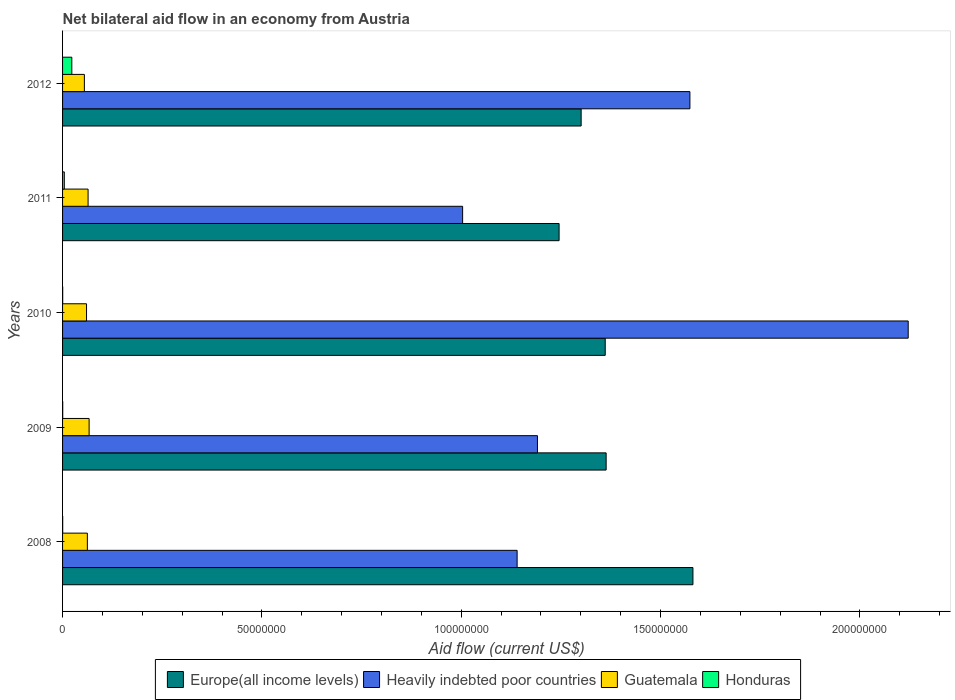Are the number of bars per tick equal to the number of legend labels?
Your answer should be compact. Yes. How many bars are there on the 5th tick from the top?
Keep it short and to the point. 4. Across all years, what is the maximum net bilateral aid flow in Guatemala?
Your answer should be very brief. 6.66e+06. Across all years, what is the minimum net bilateral aid flow in Europe(all income levels)?
Ensure brevity in your answer.  1.25e+08. What is the total net bilateral aid flow in Heavily indebted poor countries in the graph?
Ensure brevity in your answer.  7.03e+08. What is the difference between the net bilateral aid flow in Europe(all income levels) in 2010 and the net bilateral aid flow in Heavily indebted poor countries in 2009?
Offer a terse response. 1.70e+07. What is the average net bilateral aid flow in Heavily indebted poor countries per year?
Offer a terse response. 1.41e+08. In the year 2011, what is the difference between the net bilateral aid flow in Europe(all income levels) and net bilateral aid flow in Guatemala?
Give a very brief answer. 1.18e+08. In how many years, is the net bilateral aid flow in Europe(all income levels) greater than 60000000 US$?
Make the answer very short. 5. What is the ratio of the net bilateral aid flow in Heavily indebted poor countries in 2009 to that in 2011?
Offer a terse response. 1.19. Is the difference between the net bilateral aid flow in Europe(all income levels) in 2008 and 2010 greater than the difference between the net bilateral aid flow in Guatemala in 2008 and 2010?
Keep it short and to the point. Yes. What is the difference between the highest and the second highest net bilateral aid flow in Heavily indebted poor countries?
Provide a succinct answer. 5.48e+07. What is the difference between the highest and the lowest net bilateral aid flow in Honduras?
Offer a terse response. 2.29e+06. Is the sum of the net bilateral aid flow in Europe(all income levels) in 2009 and 2011 greater than the maximum net bilateral aid flow in Heavily indebted poor countries across all years?
Provide a short and direct response. Yes. What does the 2nd bar from the top in 2008 represents?
Make the answer very short. Guatemala. What does the 2nd bar from the bottom in 2011 represents?
Provide a short and direct response. Heavily indebted poor countries. How many bars are there?
Provide a succinct answer. 20. How many years are there in the graph?
Your answer should be very brief. 5. Does the graph contain any zero values?
Your response must be concise. No. Where does the legend appear in the graph?
Provide a short and direct response. Bottom center. What is the title of the graph?
Keep it short and to the point. Net bilateral aid flow in an economy from Austria. Does "Spain" appear as one of the legend labels in the graph?
Your answer should be very brief. No. What is the Aid flow (current US$) in Europe(all income levels) in 2008?
Offer a very short reply. 1.58e+08. What is the Aid flow (current US$) in Heavily indebted poor countries in 2008?
Provide a succinct answer. 1.14e+08. What is the Aid flow (current US$) in Guatemala in 2008?
Offer a very short reply. 6.22e+06. What is the Aid flow (current US$) of Honduras in 2008?
Your answer should be very brief. 3.00e+04. What is the Aid flow (current US$) in Europe(all income levels) in 2009?
Your answer should be very brief. 1.36e+08. What is the Aid flow (current US$) of Heavily indebted poor countries in 2009?
Offer a very short reply. 1.19e+08. What is the Aid flow (current US$) in Guatemala in 2009?
Your answer should be very brief. 6.66e+06. What is the Aid flow (current US$) of Europe(all income levels) in 2010?
Ensure brevity in your answer.  1.36e+08. What is the Aid flow (current US$) of Heavily indebted poor countries in 2010?
Ensure brevity in your answer.  2.12e+08. What is the Aid flow (current US$) of Guatemala in 2010?
Offer a terse response. 6.01e+06. What is the Aid flow (current US$) of Honduras in 2010?
Provide a succinct answer. 3.00e+04. What is the Aid flow (current US$) in Europe(all income levels) in 2011?
Ensure brevity in your answer.  1.25e+08. What is the Aid flow (current US$) in Heavily indebted poor countries in 2011?
Provide a succinct answer. 1.00e+08. What is the Aid flow (current US$) in Guatemala in 2011?
Give a very brief answer. 6.40e+06. What is the Aid flow (current US$) of Europe(all income levels) in 2012?
Ensure brevity in your answer.  1.30e+08. What is the Aid flow (current US$) in Heavily indebted poor countries in 2012?
Make the answer very short. 1.57e+08. What is the Aid flow (current US$) of Guatemala in 2012?
Offer a terse response. 5.47e+06. What is the Aid flow (current US$) of Honduras in 2012?
Ensure brevity in your answer.  2.32e+06. Across all years, what is the maximum Aid flow (current US$) in Europe(all income levels)?
Ensure brevity in your answer.  1.58e+08. Across all years, what is the maximum Aid flow (current US$) in Heavily indebted poor countries?
Ensure brevity in your answer.  2.12e+08. Across all years, what is the maximum Aid flow (current US$) of Guatemala?
Your answer should be compact. 6.66e+06. Across all years, what is the maximum Aid flow (current US$) of Honduras?
Ensure brevity in your answer.  2.32e+06. Across all years, what is the minimum Aid flow (current US$) in Europe(all income levels)?
Your answer should be compact. 1.25e+08. Across all years, what is the minimum Aid flow (current US$) of Heavily indebted poor countries?
Provide a short and direct response. 1.00e+08. Across all years, what is the minimum Aid flow (current US$) of Guatemala?
Give a very brief answer. 5.47e+06. What is the total Aid flow (current US$) of Europe(all income levels) in the graph?
Offer a terse response. 6.85e+08. What is the total Aid flow (current US$) in Heavily indebted poor countries in the graph?
Offer a very short reply. 7.03e+08. What is the total Aid flow (current US$) of Guatemala in the graph?
Give a very brief answer. 3.08e+07. What is the total Aid flow (current US$) in Honduras in the graph?
Your answer should be compact. 2.86e+06. What is the difference between the Aid flow (current US$) of Europe(all income levels) in 2008 and that in 2009?
Offer a very short reply. 2.18e+07. What is the difference between the Aid flow (current US$) of Heavily indebted poor countries in 2008 and that in 2009?
Keep it short and to the point. -5.10e+06. What is the difference between the Aid flow (current US$) in Guatemala in 2008 and that in 2009?
Offer a very short reply. -4.40e+05. What is the difference between the Aid flow (current US$) of Honduras in 2008 and that in 2009?
Provide a short and direct response. -10000. What is the difference between the Aid flow (current US$) in Europe(all income levels) in 2008 and that in 2010?
Ensure brevity in your answer.  2.20e+07. What is the difference between the Aid flow (current US$) of Heavily indebted poor countries in 2008 and that in 2010?
Your answer should be very brief. -9.81e+07. What is the difference between the Aid flow (current US$) in Honduras in 2008 and that in 2010?
Ensure brevity in your answer.  0. What is the difference between the Aid flow (current US$) of Europe(all income levels) in 2008 and that in 2011?
Offer a terse response. 3.36e+07. What is the difference between the Aid flow (current US$) in Heavily indebted poor countries in 2008 and that in 2011?
Your answer should be very brief. 1.37e+07. What is the difference between the Aid flow (current US$) in Guatemala in 2008 and that in 2011?
Your answer should be very brief. -1.80e+05. What is the difference between the Aid flow (current US$) of Honduras in 2008 and that in 2011?
Offer a terse response. -4.10e+05. What is the difference between the Aid flow (current US$) of Europe(all income levels) in 2008 and that in 2012?
Your answer should be very brief. 2.80e+07. What is the difference between the Aid flow (current US$) of Heavily indebted poor countries in 2008 and that in 2012?
Your answer should be compact. -4.33e+07. What is the difference between the Aid flow (current US$) of Guatemala in 2008 and that in 2012?
Your response must be concise. 7.50e+05. What is the difference between the Aid flow (current US$) of Honduras in 2008 and that in 2012?
Ensure brevity in your answer.  -2.29e+06. What is the difference between the Aid flow (current US$) in Heavily indebted poor countries in 2009 and that in 2010?
Offer a very short reply. -9.30e+07. What is the difference between the Aid flow (current US$) in Guatemala in 2009 and that in 2010?
Your answer should be compact. 6.50e+05. What is the difference between the Aid flow (current US$) of Europe(all income levels) in 2009 and that in 2011?
Your answer should be very brief. 1.18e+07. What is the difference between the Aid flow (current US$) of Heavily indebted poor countries in 2009 and that in 2011?
Provide a short and direct response. 1.88e+07. What is the difference between the Aid flow (current US$) in Honduras in 2009 and that in 2011?
Offer a very short reply. -4.00e+05. What is the difference between the Aid flow (current US$) in Europe(all income levels) in 2009 and that in 2012?
Make the answer very short. 6.27e+06. What is the difference between the Aid flow (current US$) in Heavily indebted poor countries in 2009 and that in 2012?
Make the answer very short. -3.82e+07. What is the difference between the Aid flow (current US$) of Guatemala in 2009 and that in 2012?
Offer a terse response. 1.19e+06. What is the difference between the Aid flow (current US$) in Honduras in 2009 and that in 2012?
Ensure brevity in your answer.  -2.28e+06. What is the difference between the Aid flow (current US$) in Europe(all income levels) in 2010 and that in 2011?
Your response must be concise. 1.16e+07. What is the difference between the Aid flow (current US$) of Heavily indebted poor countries in 2010 and that in 2011?
Keep it short and to the point. 1.12e+08. What is the difference between the Aid flow (current US$) of Guatemala in 2010 and that in 2011?
Your answer should be compact. -3.90e+05. What is the difference between the Aid flow (current US$) in Honduras in 2010 and that in 2011?
Make the answer very short. -4.10e+05. What is the difference between the Aid flow (current US$) of Europe(all income levels) in 2010 and that in 2012?
Keep it short and to the point. 6.04e+06. What is the difference between the Aid flow (current US$) of Heavily indebted poor countries in 2010 and that in 2012?
Provide a short and direct response. 5.48e+07. What is the difference between the Aid flow (current US$) in Guatemala in 2010 and that in 2012?
Provide a short and direct response. 5.40e+05. What is the difference between the Aid flow (current US$) in Honduras in 2010 and that in 2012?
Keep it short and to the point. -2.29e+06. What is the difference between the Aid flow (current US$) in Europe(all income levels) in 2011 and that in 2012?
Ensure brevity in your answer.  -5.53e+06. What is the difference between the Aid flow (current US$) in Heavily indebted poor countries in 2011 and that in 2012?
Your answer should be very brief. -5.70e+07. What is the difference between the Aid flow (current US$) in Guatemala in 2011 and that in 2012?
Make the answer very short. 9.30e+05. What is the difference between the Aid flow (current US$) of Honduras in 2011 and that in 2012?
Your response must be concise. -1.88e+06. What is the difference between the Aid flow (current US$) of Europe(all income levels) in 2008 and the Aid flow (current US$) of Heavily indebted poor countries in 2009?
Your answer should be compact. 3.90e+07. What is the difference between the Aid flow (current US$) in Europe(all income levels) in 2008 and the Aid flow (current US$) in Guatemala in 2009?
Your answer should be compact. 1.51e+08. What is the difference between the Aid flow (current US$) in Europe(all income levels) in 2008 and the Aid flow (current US$) in Honduras in 2009?
Offer a very short reply. 1.58e+08. What is the difference between the Aid flow (current US$) in Heavily indebted poor countries in 2008 and the Aid flow (current US$) in Guatemala in 2009?
Your response must be concise. 1.07e+08. What is the difference between the Aid flow (current US$) in Heavily indebted poor countries in 2008 and the Aid flow (current US$) in Honduras in 2009?
Provide a succinct answer. 1.14e+08. What is the difference between the Aid flow (current US$) in Guatemala in 2008 and the Aid flow (current US$) in Honduras in 2009?
Your response must be concise. 6.18e+06. What is the difference between the Aid flow (current US$) in Europe(all income levels) in 2008 and the Aid flow (current US$) in Heavily indebted poor countries in 2010?
Give a very brief answer. -5.40e+07. What is the difference between the Aid flow (current US$) of Europe(all income levels) in 2008 and the Aid flow (current US$) of Guatemala in 2010?
Make the answer very short. 1.52e+08. What is the difference between the Aid flow (current US$) of Europe(all income levels) in 2008 and the Aid flow (current US$) of Honduras in 2010?
Offer a very short reply. 1.58e+08. What is the difference between the Aid flow (current US$) of Heavily indebted poor countries in 2008 and the Aid flow (current US$) of Guatemala in 2010?
Your answer should be compact. 1.08e+08. What is the difference between the Aid flow (current US$) in Heavily indebted poor countries in 2008 and the Aid flow (current US$) in Honduras in 2010?
Give a very brief answer. 1.14e+08. What is the difference between the Aid flow (current US$) of Guatemala in 2008 and the Aid flow (current US$) of Honduras in 2010?
Your answer should be compact. 6.19e+06. What is the difference between the Aid flow (current US$) in Europe(all income levels) in 2008 and the Aid flow (current US$) in Heavily indebted poor countries in 2011?
Offer a very short reply. 5.78e+07. What is the difference between the Aid flow (current US$) of Europe(all income levels) in 2008 and the Aid flow (current US$) of Guatemala in 2011?
Offer a terse response. 1.52e+08. What is the difference between the Aid flow (current US$) in Europe(all income levels) in 2008 and the Aid flow (current US$) in Honduras in 2011?
Your answer should be compact. 1.58e+08. What is the difference between the Aid flow (current US$) in Heavily indebted poor countries in 2008 and the Aid flow (current US$) in Guatemala in 2011?
Offer a terse response. 1.08e+08. What is the difference between the Aid flow (current US$) in Heavily indebted poor countries in 2008 and the Aid flow (current US$) in Honduras in 2011?
Give a very brief answer. 1.14e+08. What is the difference between the Aid flow (current US$) in Guatemala in 2008 and the Aid flow (current US$) in Honduras in 2011?
Keep it short and to the point. 5.78e+06. What is the difference between the Aid flow (current US$) of Europe(all income levels) in 2008 and the Aid flow (current US$) of Heavily indebted poor countries in 2012?
Offer a very short reply. 7.60e+05. What is the difference between the Aid flow (current US$) of Europe(all income levels) in 2008 and the Aid flow (current US$) of Guatemala in 2012?
Your answer should be very brief. 1.53e+08. What is the difference between the Aid flow (current US$) in Europe(all income levels) in 2008 and the Aid flow (current US$) in Honduras in 2012?
Offer a very short reply. 1.56e+08. What is the difference between the Aid flow (current US$) in Heavily indebted poor countries in 2008 and the Aid flow (current US$) in Guatemala in 2012?
Make the answer very short. 1.09e+08. What is the difference between the Aid flow (current US$) of Heavily indebted poor countries in 2008 and the Aid flow (current US$) of Honduras in 2012?
Provide a succinct answer. 1.12e+08. What is the difference between the Aid flow (current US$) in Guatemala in 2008 and the Aid flow (current US$) in Honduras in 2012?
Give a very brief answer. 3.90e+06. What is the difference between the Aid flow (current US$) in Europe(all income levels) in 2009 and the Aid flow (current US$) in Heavily indebted poor countries in 2010?
Provide a short and direct response. -7.58e+07. What is the difference between the Aid flow (current US$) of Europe(all income levels) in 2009 and the Aid flow (current US$) of Guatemala in 2010?
Keep it short and to the point. 1.30e+08. What is the difference between the Aid flow (current US$) of Europe(all income levels) in 2009 and the Aid flow (current US$) of Honduras in 2010?
Your answer should be compact. 1.36e+08. What is the difference between the Aid flow (current US$) in Heavily indebted poor countries in 2009 and the Aid flow (current US$) in Guatemala in 2010?
Provide a succinct answer. 1.13e+08. What is the difference between the Aid flow (current US$) in Heavily indebted poor countries in 2009 and the Aid flow (current US$) in Honduras in 2010?
Provide a short and direct response. 1.19e+08. What is the difference between the Aid flow (current US$) in Guatemala in 2009 and the Aid flow (current US$) in Honduras in 2010?
Your answer should be very brief. 6.63e+06. What is the difference between the Aid flow (current US$) of Europe(all income levels) in 2009 and the Aid flow (current US$) of Heavily indebted poor countries in 2011?
Keep it short and to the point. 3.60e+07. What is the difference between the Aid flow (current US$) of Europe(all income levels) in 2009 and the Aid flow (current US$) of Guatemala in 2011?
Give a very brief answer. 1.30e+08. What is the difference between the Aid flow (current US$) in Europe(all income levels) in 2009 and the Aid flow (current US$) in Honduras in 2011?
Your response must be concise. 1.36e+08. What is the difference between the Aid flow (current US$) in Heavily indebted poor countries in 2009 and the Aid flow (current US$) in Guatemala in 2011?
Provide a succinct answer. 1.13e+08. What is the difference between the Aid flow (current US$) in Heavily indebted poor countries in 2009 and the Aid flow (current US$) in Honduras in 2011?
Make the answer very short. 1.19e+08. What is the difference between the Aid flow (current US$) of Guatemala in 2009 and the Aid flow (current US$) of Honduras in 2011?
Provide a succinct answer. 6.22e+06. What is the difference between the Aid flow (current US$) of Europe(all income levels) in 2009 and the Aid flow (current US$) of Heavily indebted poor countries in 2012?
Keep it short and to the point. -2.10e+07. What is the difference between the Aid flow (current US$) of Europe(all income levels) in 2009 and the Aid flow (current US$) of Guatemala in 2012?
Keep it short and to the point. 1.31e+08. What is the difference between the Aid flow (current US$) of Europe(all income levels) in 2009 and the Aid flow (current US$) of Honduras in 2012?
Your answer should be very brief. 1.34e+08. What is the difference between the Aid flow (current US$) of Heavily indebted poor countries in 2009 and the Aid flow (current US$) of Guatemala in 2012?
Give a very brief answer. 1.14e+08. What is the difference between the Aid flow (current US$) of Heavily indebted poor countries in 2009 and the Aid flow (current US$) of Honduras in 2012?
Offer a very short reply. 1.17e+08. What is the difference between the Aid flow (current US$) in Guatemala in 2009 and the Aid flow (current US$) in Honduras in 2012?
Your answer should be very brief. 4.34e+06. What is the difference between the Aid flow (current US$) of Europe(all income levels) in 2010 and the Aid flow (current US$) of Heavily indebted poor countries in 2011?
Keep it short and to the point. 3.58e+07. What is the difference between the Aid flow (current US$) of Europe(all income levels) in 2010 and the Aid flow (current US$) of Guatemala in 2011?
Give a very brief answer. 1.30e+08. What is the difference between the Aid flow (current US$) of Europe(all income levels) in 2010 and the Aid flow (current US$) of Honduras in 2011?
Your answer should be very brief. 1.36e+08. What is the difference between the Aid flow (current US$) of Heavily indebted poor countries in 2010 and the Aid flow (current US$) of Guatemala in 2011?
Offer a very short reply. 2.06e+08. What is the difference between the Aid flow (current US$) in Heavily indebted poor countries in 2010 and the Aid flow (current US$) in Honduras in 2011?
Ensure brevity in your answer.  2.12e+08. What is the difference between the Aid flow (current US$) of Guatemala in 2010 and the Aid flow (current US$) of Honduras in 2011?
Ensure brevity in your answer.  5.57e+06. What is the difference between the Aid flow (current US$) of Europe(all income levels) in 2010 and the Aid flow (current US$) of Heavily indebted poor countries in 2012?
Provide a succinct answer. -2.12e+07. What is the difference between the Aid flow (current US$) in Europe(all income levels) in 2010 and the Aid flow (current US$) in Guatemala in 2012?
Make the answer very short. 1.31e+08. What is the difference between the Aid flow (current US$) of Europe(all income levels) in 2010 and the Aid flow (current US$) of Honduras in 2012?
Ensure brevity in your answer.  1.34e+08. What is the difference between the Aid flow (current US$) of Heavily indebted poor countries in 2010 and the Aid flow (current US$) of Guatemala in 2012?
Make the answer very short. 2.07e+08. What is the difference between the Aid flow (current US$) of Heavily indebted poor countries in 2010 and the Aid flow (current US$) of Honduras in 2012?
Offer a terse response. 2.10e+08. What is the difference between the Aid flow (current US$) in Guatemala in 2010 and the Aid flow (current US$) in Honduras in 2012?
Offer a terse response. 3.69e+06. What is the difference between the Aid flow (current US$) in Europe(all income levels) in 2011 and the Aid flow (current US$) in Heavily indebted poor countries in 2012?
Provide a short and direct response. -3.28e+07. What is the difference between the Aid flow (current US$) of Europe(all income levels) in 2011 and the Aid flow (current US$) of Guatemala in 2012?
Ensure brevity in your answer.  1.19e+08. What is the difference between the Aid flow (current US$) in Europe(all income levels) in 2011 and the Aid flow (current US$) in Honduras in 2012?
Your answer should be compact. 1.22e+08. What is the difference between the Aid flow (current US$) of Heavily indebted poor countries in 2011 and the Aid flow (current US$) of Guatemala in 2012?
Your answer should be very brief. 9.49e+07. What is the difference between the Aid flow (current US$) of Heavily indebted poor countries in 2011 and the Aid flow (current US$) of Honduras in 2012?
Provide a succinct answer. 9.80e+07. What is the difference between the Aid flow (current US$) of Guatemala in 2011 and the Aid flow (current US$) of Honduras in 2012?
Make the answer very short. 4.08e+06. What is the average Aid flow (current US$) of Europe(all income levels) per year?
Your answer should be very brief. 1.37e+08. What is the average Aid flow (current US$) in Heavily indebted poor countries per year?
Your answer should be compact. 1.41e+08. What is the average Aid flow (current US$) in Guatemala per year?
Offer a terse response. 6.15e+06. What is the average Aid flow (current US$) of Honduras per year?
Give a very brief answer. 5.72e+05. In the year 2008, what is the difference between the Aid flow (current US$) in Europe(all income levels) and Aid flow (current US$) in Heavily indebted poor countries?
Offer a terse response. 4.41e+07. In the year 2008, what is the difference between the Aid flow (current US$) of Europe(all income levels) and Aid flow (current US$) of Guatemala?
Your answer should be compact. 1.52e+08. In the year 2008, what is the difference between the Aid flow (current US$) in Europe(all income levels) and Aid flow (current US$) in Honduras?
Ensure brevity in your answer.  1.58e+08. In the year 2008, what is the difference between the Aid flow (current US$) of Heavily indebted poor countries and Aid flow (current US$) of Guatemala?
Offer a very short reply. 1.08e+08. In the year 2008, what is the difference between the Aid flow (current US$) in Heavily indebted poor countries and Aid flow (current US$) in Honduras?
Your answer should be very brief. 1.14e+08. In the year 2008, what is the difference between the Aid flow (current US$) of Guatemala and Aid flow (current US$) of Honduras?
Offer a terse response. 6.19e+06. In the year 2009, what is the difference between the Aid flow (current US$) of Europe(all income levels) and Aid flow (current US$) of Heavily indebted poor countries?
Your answer should be compact. 1.72e+07. In the year 2009, what is the difference between the Aid flow (current US$) of Europe(all income levels) and Aid flow (current US$) of Guatemala?
Offer a very short reply. 1.30e+08. In the year 2009, what is the difference between the Aid flow (current US$) in Europe(all income levels) and Aid flow (current US$) in Honduras?
Your answer should be very brief. 1.36e+08. In the year 2009, what is the difference between the Aid flow (current US$) of Heavily indebted poor countries and Aid flow (current US$) of Guatemala?
Keep it short and to the point. 1.12e+08. In the year 2009, what is the difference between the Aid flow (current US$) of Heavily indebted poor countries and Aid flow (current US$) of Honduras?
Give a very brief answer. 1.19e+08. In the year 2009, what is the difference between the Aid flow (current US$) of Guatemala and Aid flow (current US$) of Honduras?
Ensure brevity in your answer.  6.62e+06. In the year 2010, what is the difference between the Aid flow (current US$) in Europe(all income levels) and Aid flow (current US$) in Heavily indebted poor countries?
Your response must be concise. -7.60e+07. In the year 2010, what is the difference between the Aid flow (current US$) in Europe(all income levels) and Aid flow (current US$) in Guatemala?
Offer a terse response. 1.30e+08. In the year 2010, what is the difference between the Aid flow (current US$) in Europe(all income levels) and Aid flow (current US$) in Honduras?
Ensure brevity in your answer.  1.36e+08. In the year 2010, what is the difference between the Aid flow (current US$) of Heavily indebted poor countries and Aid flow (current US$) of Guatemala?
Keep it short and to the point. 2.06e+08. In the year 2010, what is the difference between the Aid flow (current US$) of Heavily indebted poor countries and Aid flow (current US$) of Honduras?
Offer a terse response. 2.12e+08. In the year 2010, what is the difference between the Aid flow (current US$) in Guatemala and Aid flow (current US$) in Honduras?
Your answer should be very brief. 5.98e+06. In the year 2011, what is the difference between the Aid flow (current US$) in Europe(all income levels) and Aid flow (current US$) in Heavily indebted poor countries?
Make the answer very short. 2.42e+07. In the year 2011, what is the difference between the Aid flow (current US$) of Europe(all income levels) and Aid flow (current US$) of Guatemala?
Give a very brief answer. 1.18e+08. In the year 2011, what is the difference between the Aid flow (current US$) of Europe(all income levels) and Aid flow (current US$) of Honduras?
Ensure brevity in your answer.  1.24e+08. In the year 2011, what is the difference between the Aid flow (current US$) of Heavily indebted poor countries and Aid flow (current US$) of Guatemala?
Provide a short and direct response. 9.40e+07. In the year 2011, what is the difference between the Aid flow (current US$) in Heavily indebted poor countries and Aid flow (current US$) in Honduras?
Your answer should be very brief. 9.99e+07. In the year 2011, what is the difference between the Aid flow (current US$) of Guatemala and Aid flow (current US$) of Honduras?
Your response must be concise. 5.96e+06. In the year 2012, what is the difference between the Aid flow (current US$) of Europe(all income levels) and Aid flow (current US$) of Heavily indebted poor countries?
Provide a succinct answer. -2.73e+07. In the year 2012, what is the difference between the Aid flow (current US$) in Europe(all income levels) and Aid flow (current US$) in Guatemala?
Provide a short and direct response. 1.25e+08. In the year 2012, what is the difference between the Aid flow (current US$) in Europe(all income levels) and Aid flow (current US$) in Honduras?
Provide a succinct answer. 1.28e+08. In the year 2012, what is the difference between the Aid flow (current US$) in Heavily indebted poor countries and Aid flow (current US$) in Guatemala?
Offer a very short reply. 1.52e+08. In the year 2012, what is the difference between the Aid flow (current US$) in Heavily indebted poor countries and Aid flow (current US$) in Honduras?
Your response must be concise. 1.55e+08. In the year 2012, what is the difference between the Aid flow (current US$) of Guatemala and Aid flow (current US$) of Honduras?
Offer a terse response. 3.15e+06. What is the ratio of the Aid flow (current US$) of Europe(all income levels) in 2008 to that in 2009?
Provide a succinct answer. 1.16. What is the ratio of the Aid flow (current US$) in Heavily indebted poor countries in 2008 to that in 2009?
Keep it short and to the point. 0.96. What is the ratio of the Aid flow (current US$) of Guatemala in 2008 to that in 2009?
Ensure brevity in your answer.  0.93. What is the ratio of the Aid flow (current US$) of Honduras in 2008 to that in 2009?
Offer a terse response. 0.75. What is the ratio of the Aid flow (current US$) of Europe(all income levels) in 2008 to that in 2010?
Offer a terse response. 1.16. What is the ratio of the Aid flow (current US$) in Heavily indebted poor countries in 2008 to that in 2010?
Keep it short and to the point. 0.54. What is the ratio of the Aid flow (current US$) of Guatemala in 2008 to that in 2010?
Offer a very short reply. 1.03. What is the ratio of the Aid flow (current US$) of Europe(all income levels) in 2008 to that in 2011?
Provide a succinct answer. 1.27. What is the ratio of the Aid flow (current US$) in Heavily indebted poor countries in 2008 to that in 2011?
Provide a succinct answer. 1.14. What is the ratio of the Aid flow (current US$) in Guatemala in 2008 to that in 2011?
Your answer should be compact. 0.97. What is the ratio of the Aid flow (current US$) of Honduras in 2008 to that in 2011?
Make the answer very short. 0.07. What is the ratio of the Aid flow (current US$) of Europe(all income levels) in 2008 to that in 2012?
Ensure brevity in your answer.  1.22. What is the ratio of the Aid flow (current US$) in Heavily indebted poor countries in 2008 to that in 2012?
Your answer should be compact. 0.72. What is the ratio of the Aid flow (current US$) of Guatemala in 2008 to that in 2012?
Make the answer very short. 1.14. What is the ratio of the Aid flow (current US$) in Honduras in 2008 to that in 2012?
Offer a terse response. 0.01. What is the ratio of the Aid flow (current US$) in Heavily indebted poor countries in 2009 to that in 2010?
Ensure brevity in your answer.  0.56. What is the ratio of the Aid flow (current US$) of Guatemala in 2009 to that in 2010?
Offer a very short reply. 1.11. What is the ratio of the Aid flow (current US$) of Europe(all income levels) in 2009 to that in 2011?
Make the answer very short. 1.09. What is the ratio of the Aid flow (current US$) of Heavily indebted poor countries in 2009 to that in 2011?
Make the answer very short. 1.19. What is the ratio of the Aid flow (current US$) of Guatemala in 2009 to that in 2011?
Offer a very short reply. 1.04. What is the ratio of the Aid flow (current US$) of Honduras in 2009 to that in 2011?
Offer a terse response. 0.09. What is the ratio of the Aid flow (current US$) in Europe(all income levels) in 2009 to that in 2012?
Give a very brief answer. 1.05. What is the ratio of the Aid flow (current US$) in Heavily indebted poor countries in 2009 to that in 2012?
Provide a short and direct response. 0.76. What is the ratio of the Aid flow (current US$) in Guatemala in 2009 to that in 2012?
Give a very brief answer. 1.22. What is the ratio of the Aid flow (current US$) of Honduras in 2009 to that in 2012?
Offer a very short reply. 0.02. What is the ratio of the Aid flow (current US$) in Europe(all income levels) in 2010 to that in 2011?
Offer a very short reply. 1.09. What is the ratio of the Aid flow (current US$) of Heavily indebted poor countries in 2010 to that in 2011?
Your answer should be compact. 2.11. What is the ratio of the Aid flow (current US$) in Guatemala in 2010 to that in 2011?
Your response must be concise. 0.94. What is the ratio of the Aid flow (current US$) of Honduras in 2010 to that in 2011?
Your answer should be compact. 0.07. What is the ratio of the Aid flow (current US$) in Europe(all income levels) in 2010 to that in 2012?
Give a very brief answer. 1.05. What is the ratio of the Aid flow (current US$) of Heavily indebted poor countries in 2010 to that in 2012?
Make the answer very short. 1.35. What is the ratio of the Aid flow (current US$) in Guatemala in 2010 to that in 2012?
Give a very brief answer. 1.1. What is the ratio of the Aid flow (current US$) in Honduras in 2010 to that in 2012?
Ensure brevity in your answer.  0.01. What is the ratio of the Aid flow (current US$) in Europe(all income levels) in 2011 to that in 2012?
Your response must be concise. 0.96. What is the ratio of the Aid flow (current US$) in Heavily indebted poor countries in 2011 to that in 2012?
Give a very brief answer. 0.64. What is the ratio of the Aid flow (current US$) of Guatemala in 2011 to that in 2012?
Your response must be concise. 1.17. What is the ratio of the Aid flow (current US$) of Honduras in 2011 to that in 2012?
Provide a short and direct response. 0.19. What is the difference between the highest and the second highest Aid flow (current US$) in Europe(all income levels)?
Your answer should be very brief. 2.18e+07. What is the difference between the highest and the second highest Aid flow (current US$) in Heavily indebted poor countries?
Make the answer very short. 5.48e+07. What is the difference between the highest and the second highest Aid flow (current US$) in Honduras?
Provide a short and direct response. 1.88e+06. What is the difference between the highest and the lowest Aid flow (current US$) of Europe(all income levels)?
Offer a very short reply. 3.36e+07. What is the difference between the highest and the lowest Aid flow (current US$) of Heavily indebted poor countries?
Keep it short and to the point. 1.12e+08. What is the difference between the highest and the lowest Aid flow (current US$) in Guatemala?
Keep it short and to the point. 1.19e+06. What is the difference between the highest and the lowest Aid flow (current US$) in Honduras?
Offer a very short reply. 2.29e+06. 